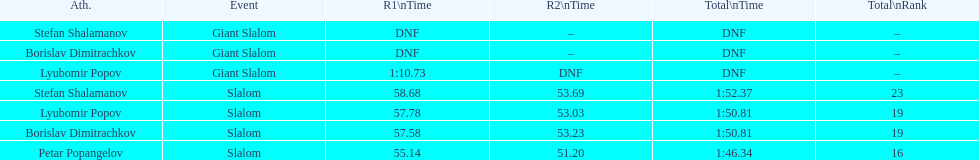In the slalom event, what is the rank number for stefan shalamanov? 23. 